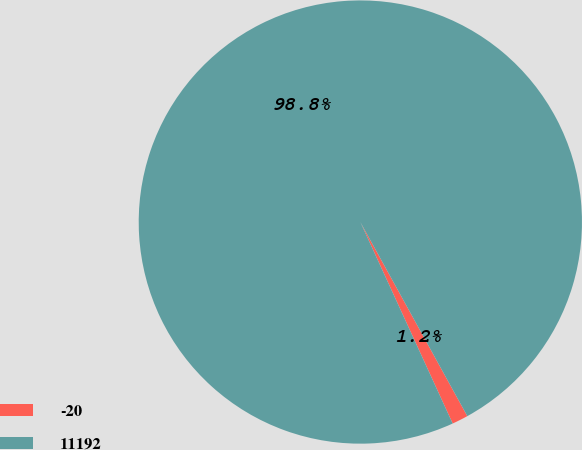Convert chart to OTSL. <chart><loc_0><loc_0><loc_500><loc_500><pie_chart><fcel>-20<fcel>11192<nl><fcel>1.18%<fcel>98.82%<nl></chart> 